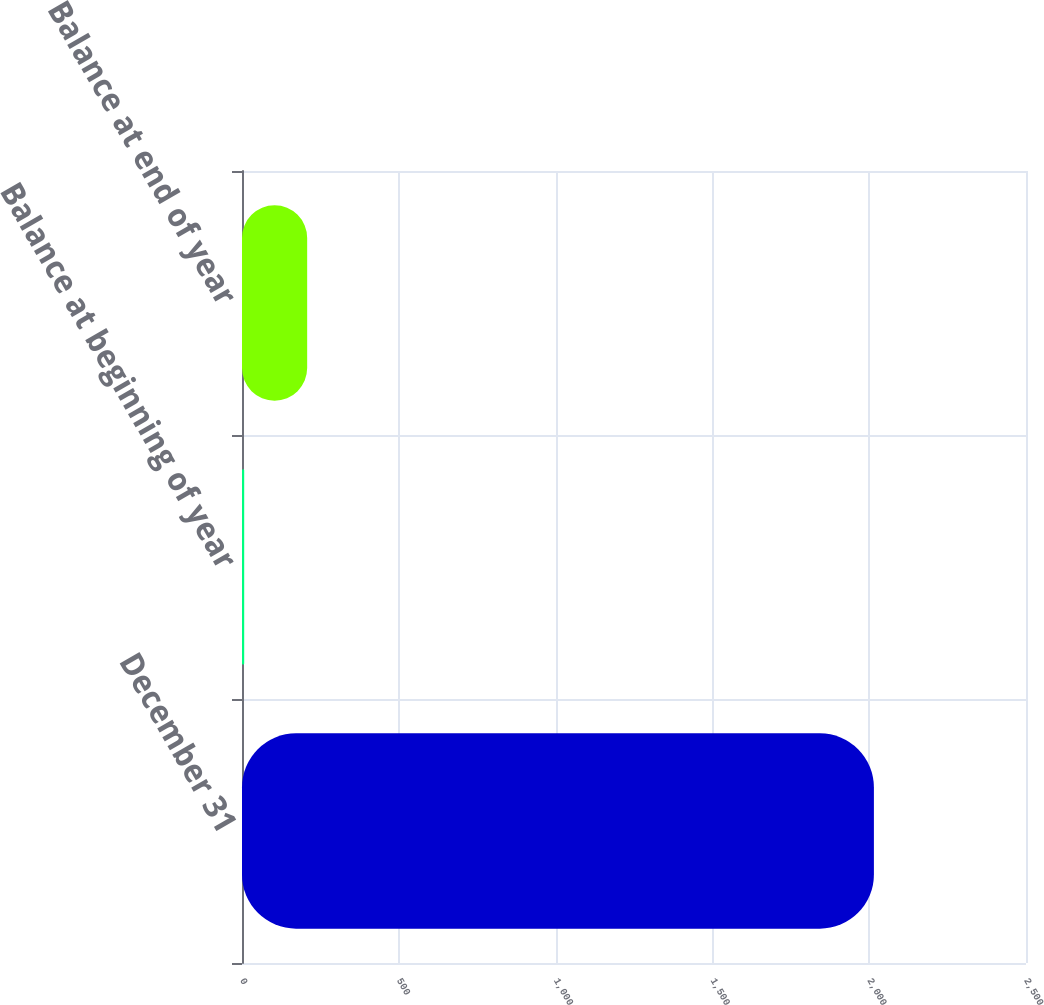Convert chart to OTSL. <chart><loc_0><loc_0><loc_500><loc_500><bar_chart><fcel>December 31<fcel>Balance at beginning of year<fcel>Balance at end of year<nl><fcel>2015<fcel>7<fcel>207.8<nl></chart> 